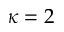Convert formula to latex. <formula><loc_0><loc_0><loc_500><loc_500>\kappa = 2</formula> 